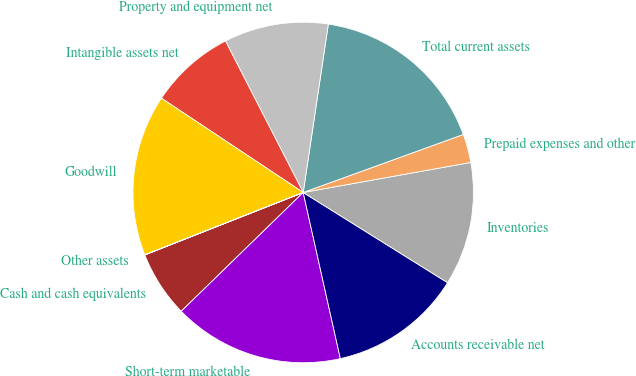Convert chart. <chart><loc_0><loc_0><loc_500><loc_500><pie_chart><fcel>Cash and cash equivalents<fcel>Short-term marketable<fcel>Accounts receivable net<fcel>Inventories<fcel>Prepaid expenses and other<fcel>Total current assets<fcel>Property and equipment net<fcel>Intangible assets net<fcel>Goodwill<fcel>Other assets<nl><fcel>6.31%<fcel>16.21%<fcel>12.61%<fcel>11.71%<fcel>2.71%<fcel>17.11%<fcel>9.91%<fcel>8.11%<fcel>15.31%<fcel>0.01%<nl></chart> 